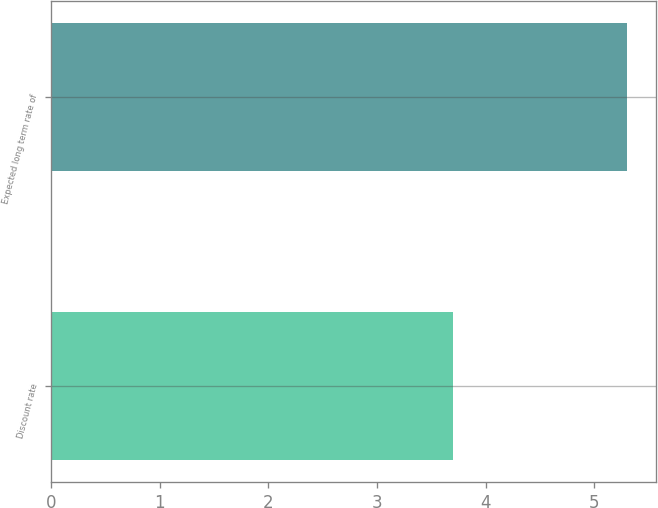Convert chart to OTSL. <chart><loc_0><loc_0><loc_500><loc_500><bar_chart><fcel>Discount rate<fcel>Expected long term rate of<nl><fcel>3.7<fcel>5.3<nl></chart> 